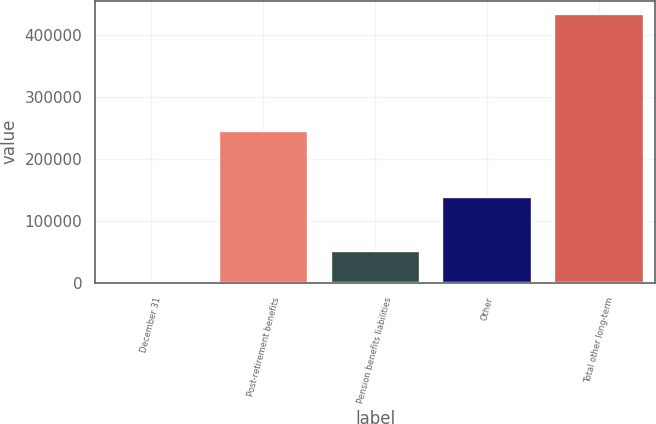Convert chart. <chart><loc_0><loc_0><loc_500><loc_500><bar_chart><fcel>December 31<fcel>Post-retirement benefits<fcel>Pension benefits liabilities<fcel>Other<fcel>Total other long-term<nl><fcel>2013<fcel>245460<fcel>50842<fcel>137766<fcel>434068<nl></chart> 